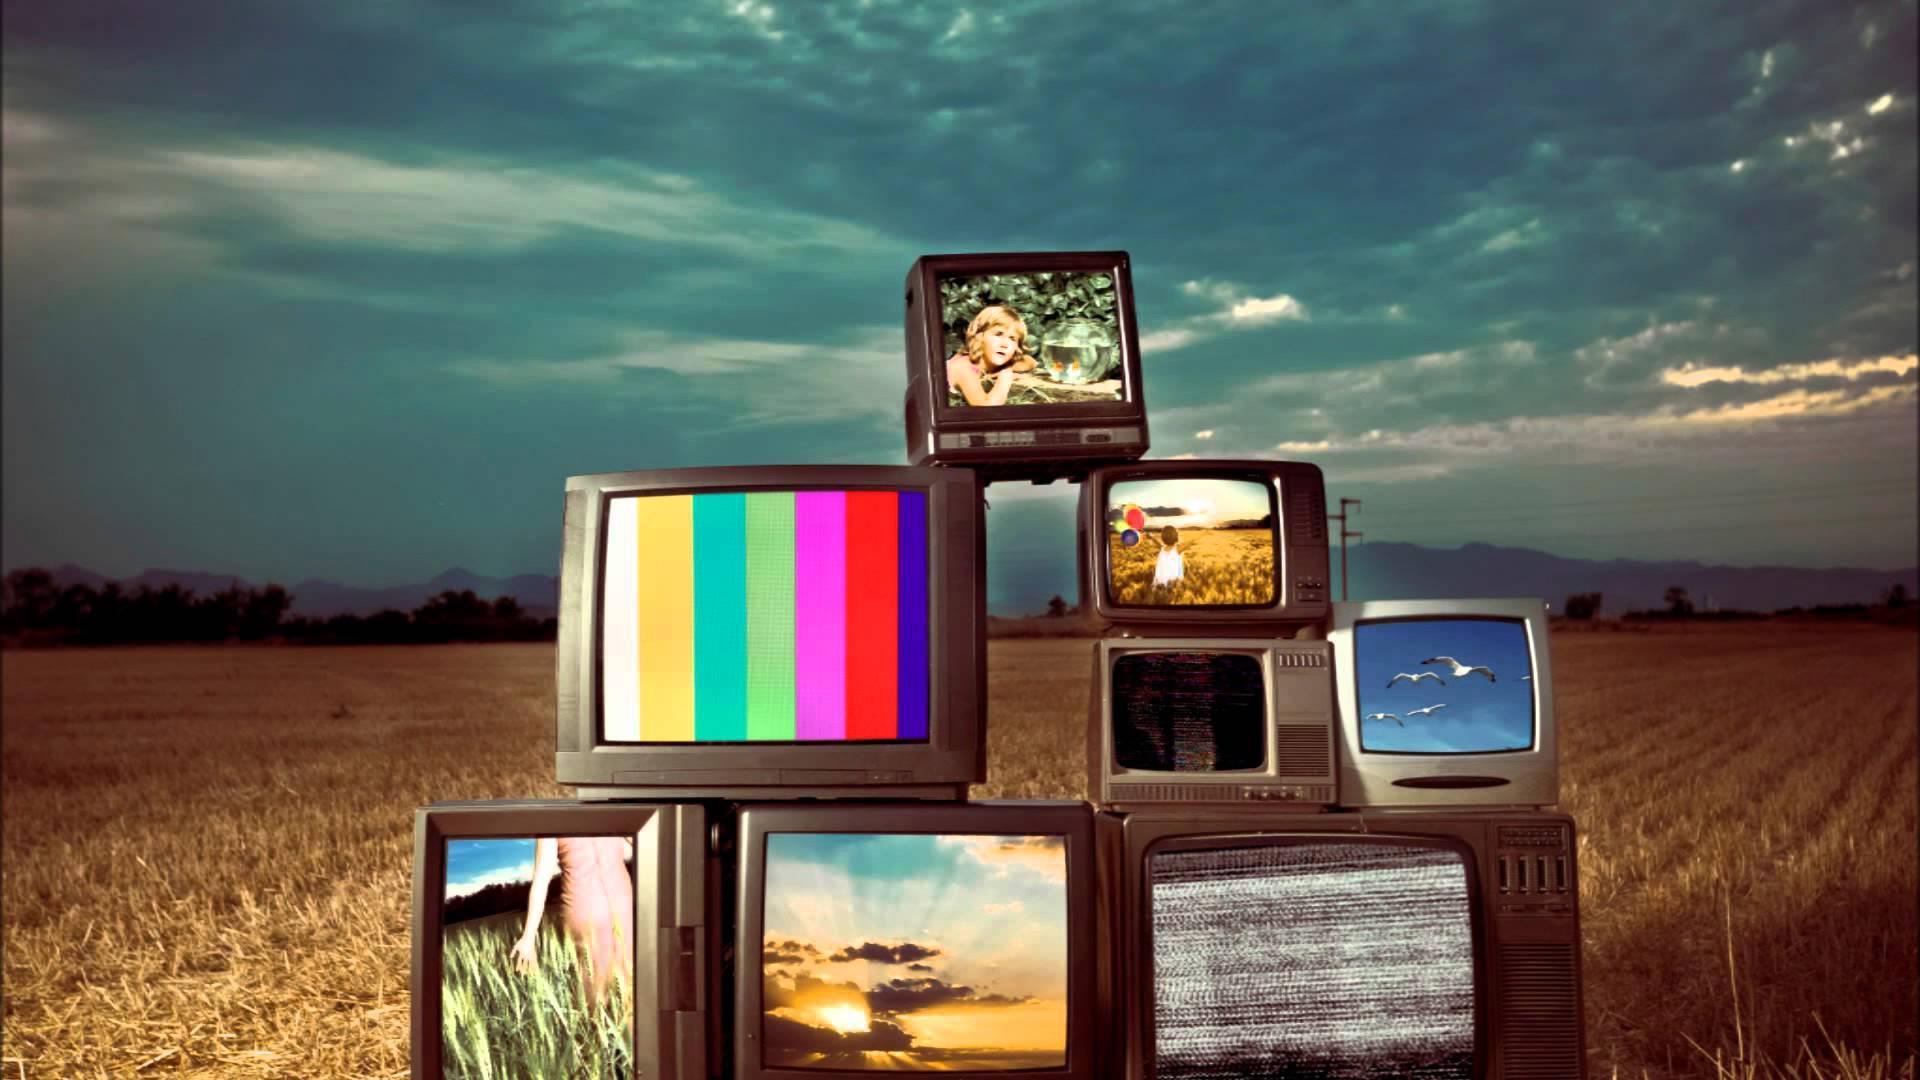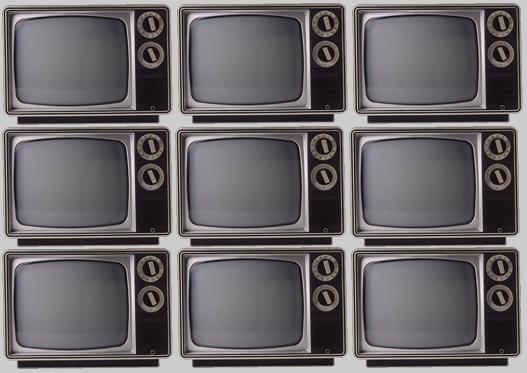The first image is the image on the left, the second image is the image on the right. Considering the images on both sides, is "Each image contains at least one stack that includes multiple different models of old-fashioned TV sets." valid? Answer yes or no. No. 